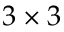<formula> <loc_0><loc_0><loc_500><loc_500>3 \times 3</formula> 